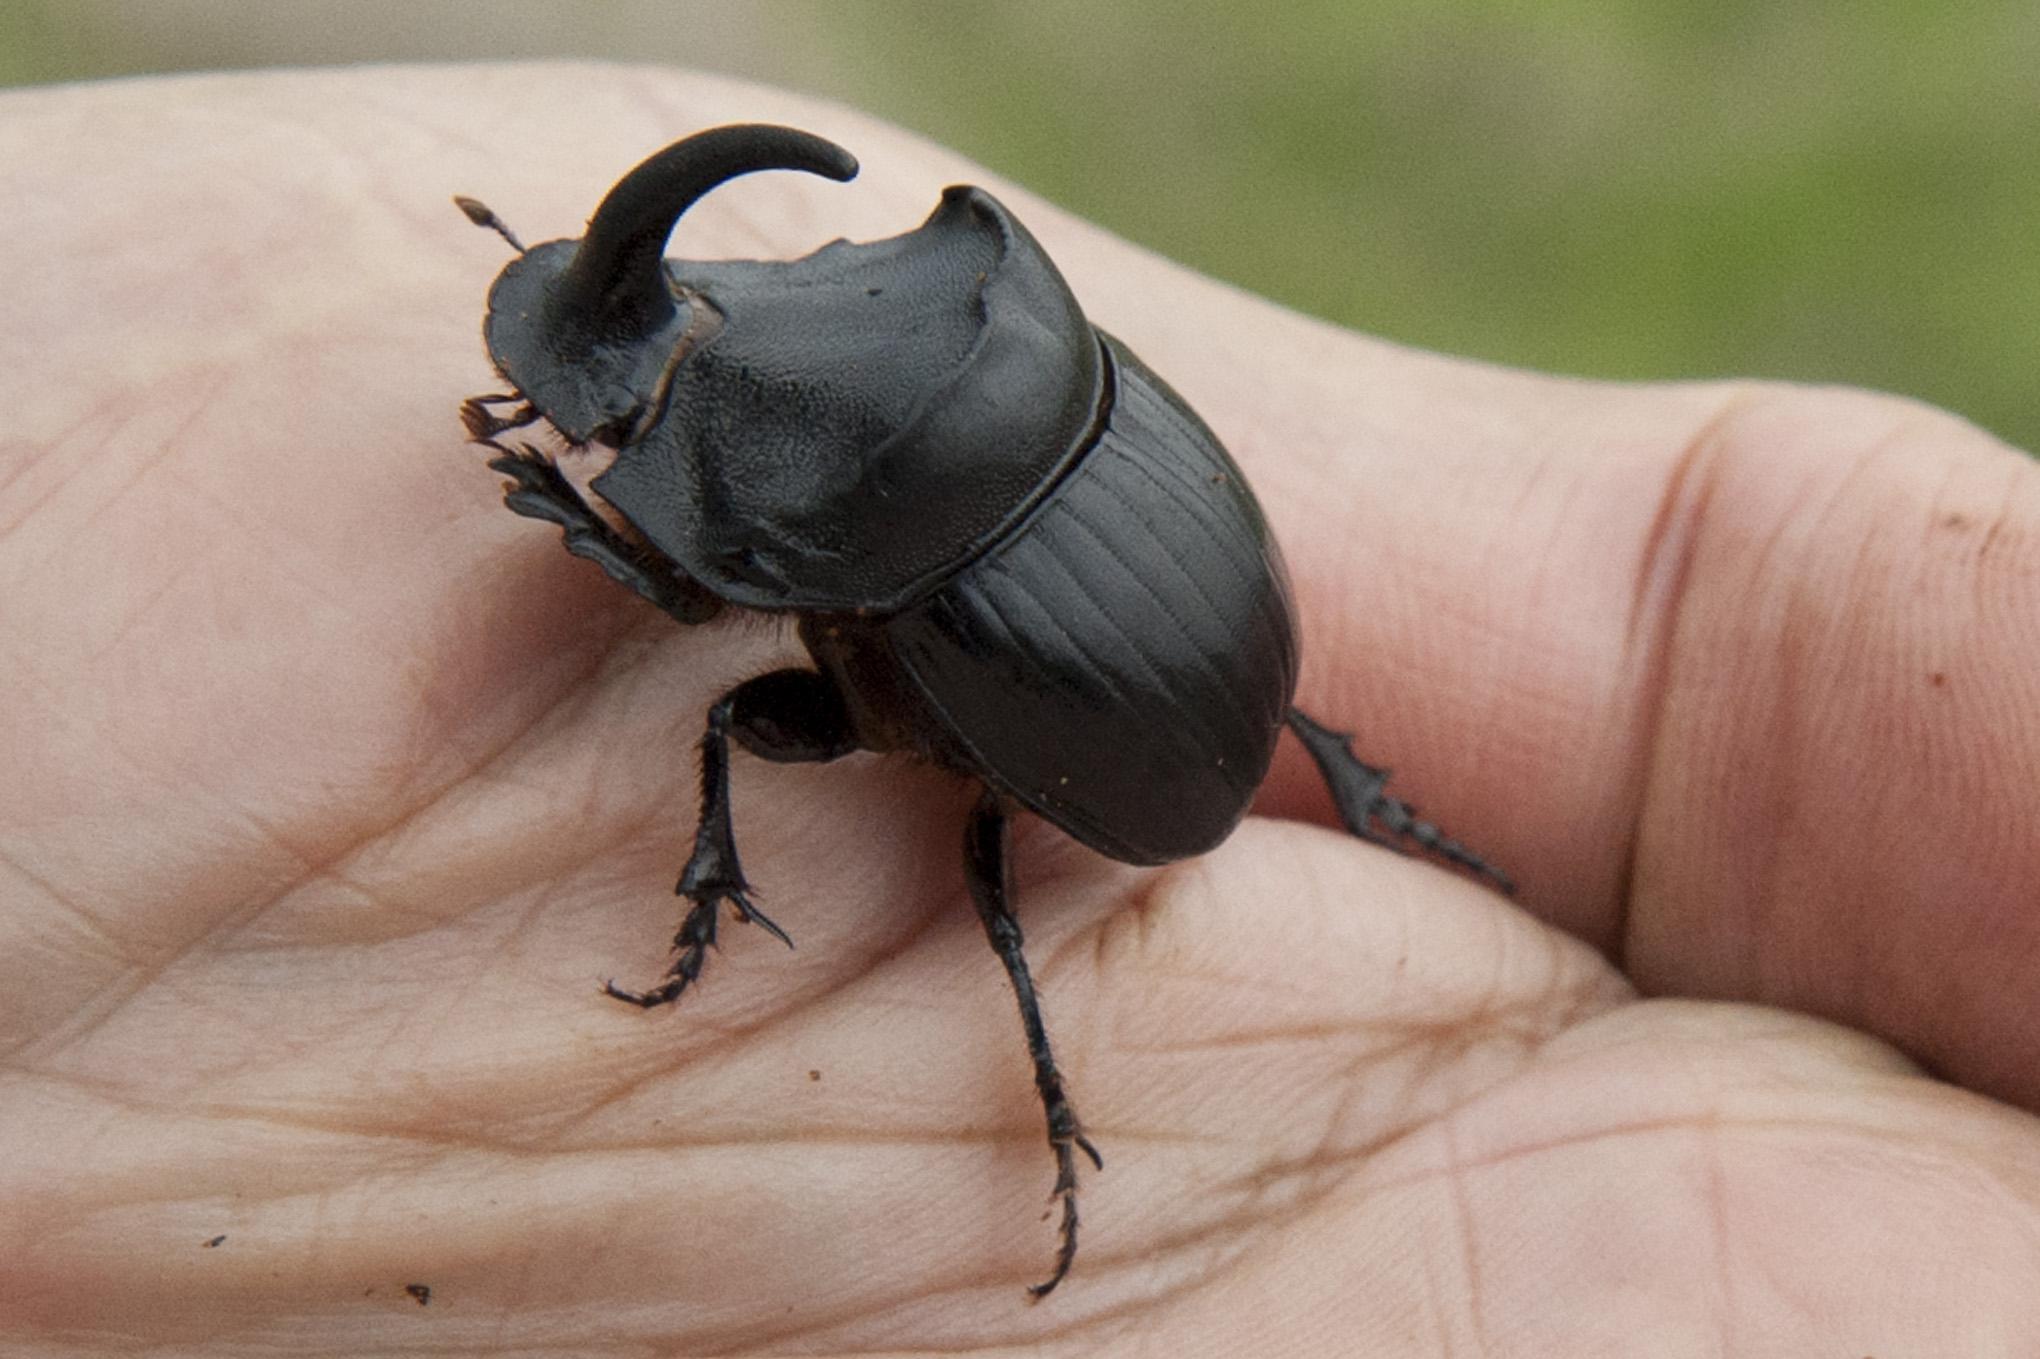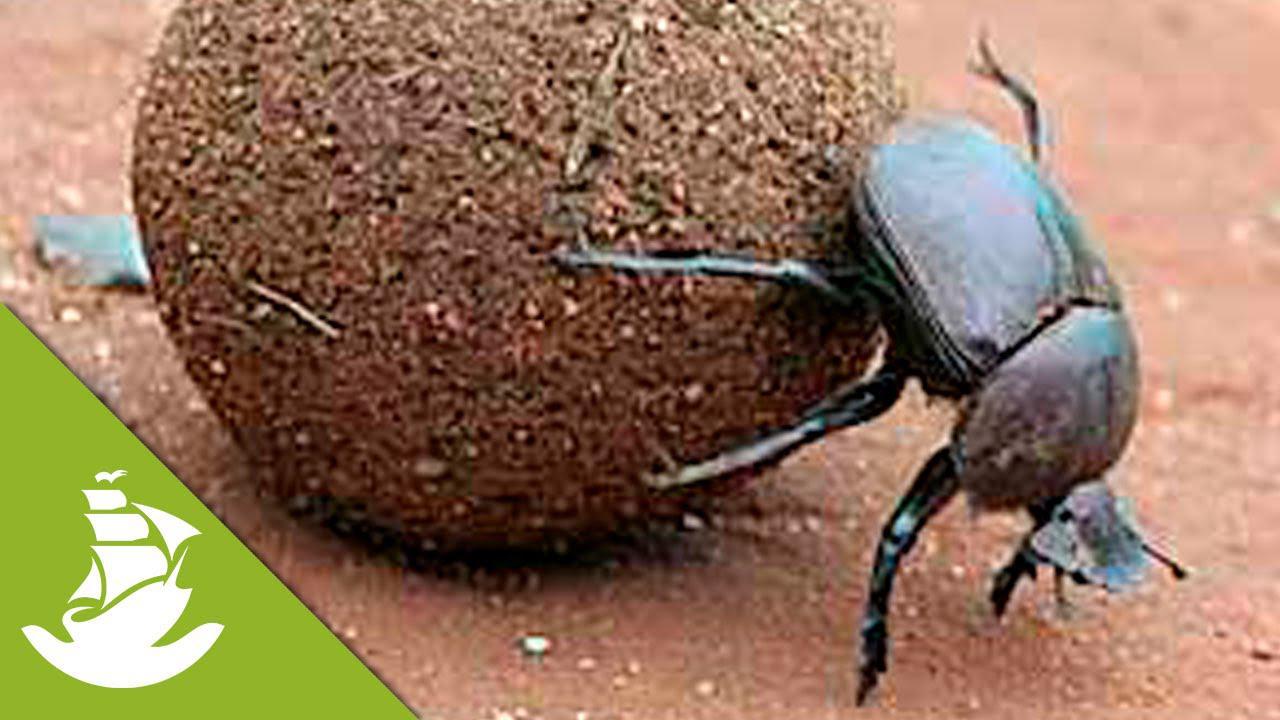The first image is the image on the left, the second image is the image on the right. Analyze the images presented: Is the assertion "An image contains two dung beetles." valid? Answer yes or no. No. The first image is the image on the left, the second image is the image on the right. Evaluate the accuracy of this statement regarding the images: "One image includes a beetle that is not in contact with a ball shape, and the other shows a beetle perched on a ball with its front legs touching the ground.". Is it true? Answer yes or no. Yes. 